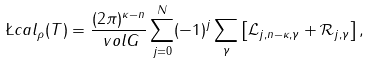Convert formula to latex. <formula><loc_0><loc_0><loc_500><loc_500>\L c a l _ { \rho } ( T ) & = \frac { ( 2 \pi ) ^ { \kappa - n } } { \ v o l G } \sum _ { j = 0 } ^ { N } ( - 1 ) ^ { j } \sum _ { \gamma } \left [ \mathcal { L } _ { j , n - \kappa , \gamma } + \mathcal { R } _ { j , \gamma } \right ] ,</formula> 